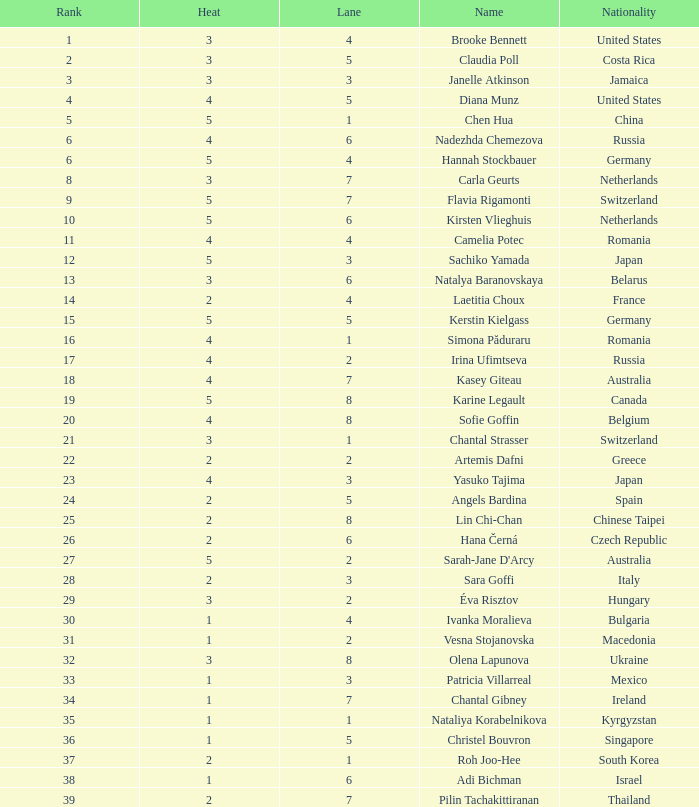What is the average rank greater than 3 and heat exceeding 5? None. 